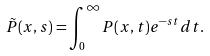<formula> <loc_0><loc_0><loc_500><loc_500>\tilde { P } ( x , s ) = \int ^ { \infty } _ { 0 } P ( x , t ) e ^ { - s t } d t .</formula> 